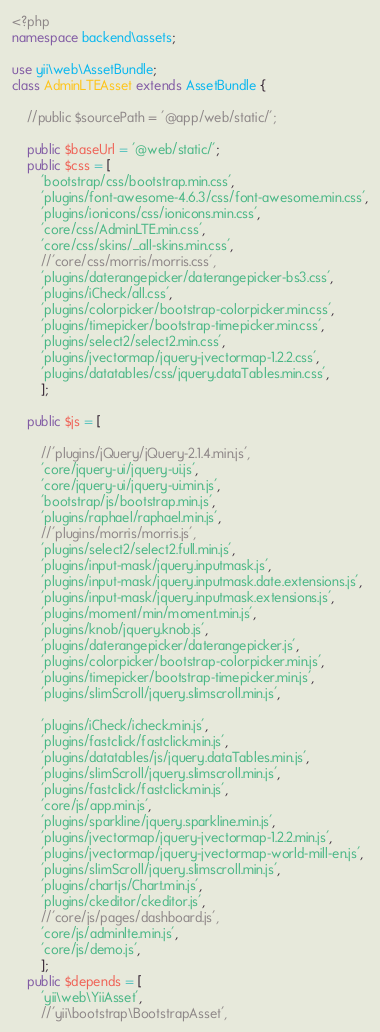Convert code to text. <code><loc_0><loc_0><loc_500><loc_500><_PHP_><?php
namespace backend\assets;

use yii\web\AssetBundle;
class AdminLTEAsset extends AssetBundle {
	
    //public $sourcePath = '@app/web/static/';

    public $baseUrl = '@web/static/';
    public $css = [
		'bootstrap/css/bootstrap.min.css',
		'plugins/font-awesome-4.6.3/css/font-awesome.min.css',
		'plugins/ionicons/css/ionicons.min.css',
		'core/css/AdminLTE.min.css',
		'core/css/skins/_all-skins.min.css',
		//'core/css/morris/morris.css',
		'plugins/daterangepicker/daterangepicker-bs3.css',
		'plugins/iCheck/all.css',
		'plugins/colorpicker/bootstrap-colorpicker.min.css',
		'plugins/timepicker/bootstrap-timepicker.min.css',
		'plugins/select2/select2.min.css',
		'plugins/jvectormap/jquery-jvectormap-1.2.2.css',
		'plugins/datatables/css/jquery.dataTables.min.css',
        ];
		
    public $js = [       
		
		//'plugins/jQuery/jQuery-2.1.4.min.js',
		'core/jquery-ui/jquery-ui.js',
		'core/jquery-ui/jquery-ui.min.js',
		'bootstrap/js/bootstrap.min.js',
		'plugins/raphael/raphael.min.js',
		//'plugins/morris/morris.js',
		'plugins/select2/select2.full.min.js',
		'plugins/input-mask/jquery.inputmask.js',
		'plugins/input-mask/jquery.inputmask.date.extensions.js',
		'plugins/input-mask/jquery.inputmask.extensions.js',
		'plugins/moment/min/moment.min.js',
		'plugins/knob/jquery.knob.js',
		'plugins/daterangepicker/daterangepicker.js',
		'plugins/colorpicker/bootstrap-colorpicker.min.js',
		'plugins/timepicker/bootstrap-timepicker.min.js',
		'plugins/slimScroll/jquery.slimscroll.min.js',
		
		'plugins/iCheck/icheck.min.js',
		'plugins/fastclick/fastclick.min.js',
		'plugins/datatables/js/jquery.dataTables.min.js',
		'plugins/slimScroll/jquery.slimscroll.min.js',
		'plugins/fastclick/fastclick.min.js',
		'core/js/app.min.js',
		'plugins/sparkline/jquery.sparkline.min.js',
		'plugins/jvectormap/jquery-jvectormap-1.2.2.min.js',
		'plugins/jvectormap/jquery-jvectormap-world-mill-en.js',
		'plugins/slimScroll/jquery.slimscroll.min.js',
		'plugins/chartjs/Chart.min.js',
		'plugins/ckeditor/ckeditor.js',	
		//'core/js/pages/dashboard.js',
		'core/js/adminlte.min.js',
		'core/js/demo.js',
        ];
    public $depends = [
        'yii\web\YiiAsset',
        //'yii\bootstrap\BootstrapAsset',</code> 